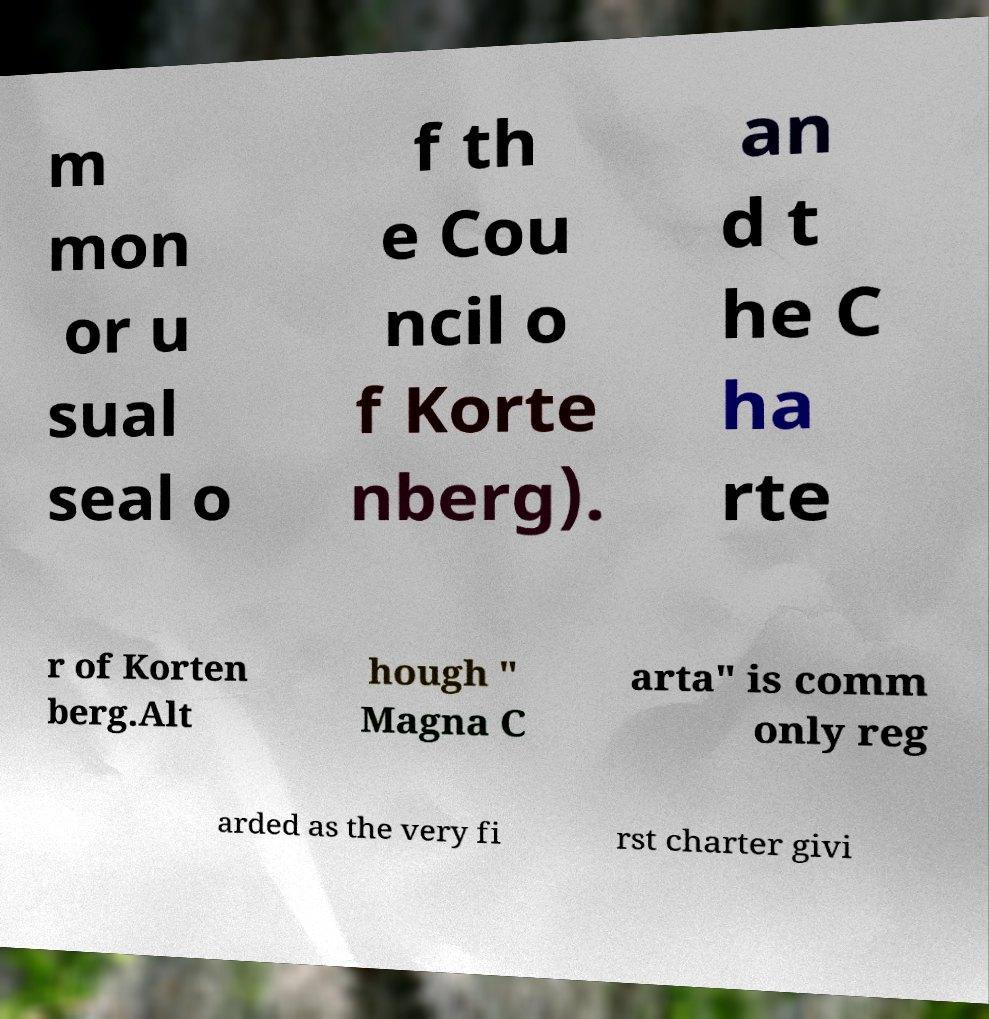I need the written content from this picture converted into text. Can you do that? m mon or u sual seal o f th e Cou ncil o f Korte nberg). an d t he C ha rte r of Korten berg.Alt hough " Magna C arta" is comm only reg arded as the very fi rst charter givi 